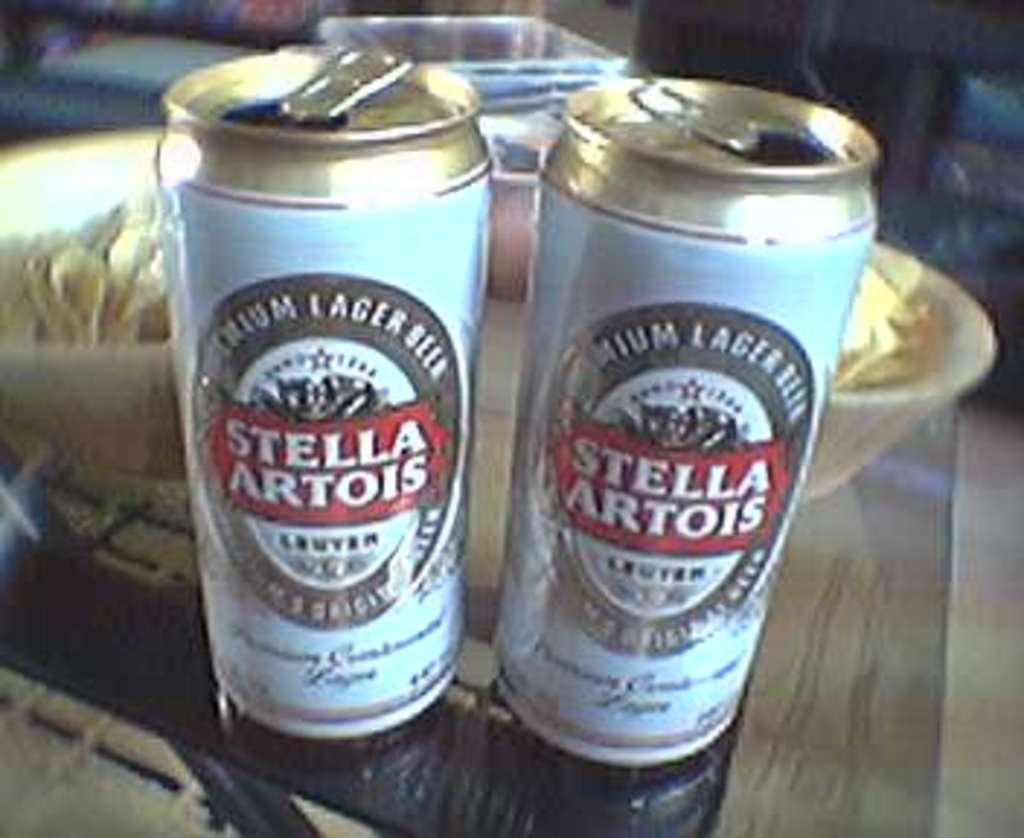<image>
Create a compact narrative representing the image presented. Two cans of the beer called stella artois sitting next to each other. 